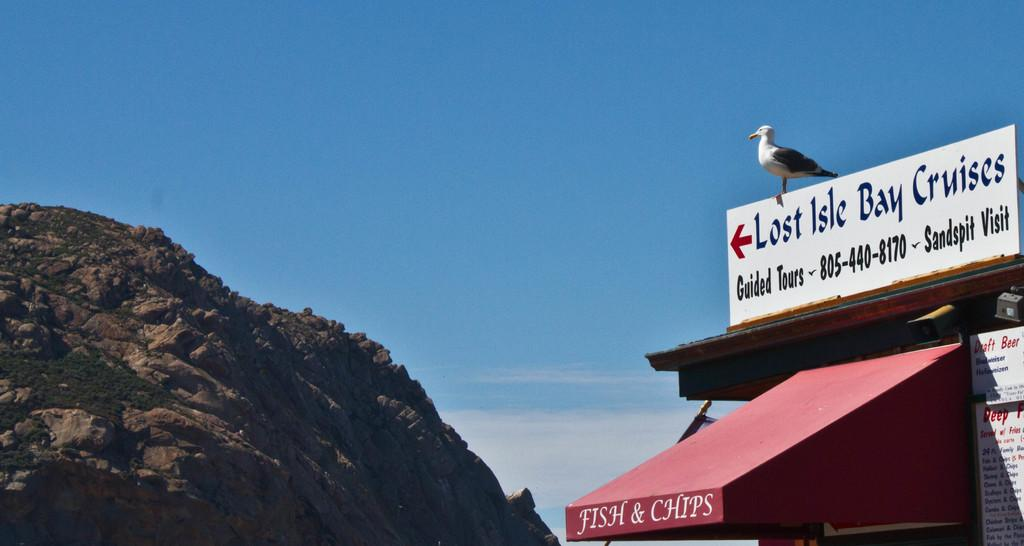<image>
Relay a brief, clear account of the picture shown. A seagull sits on a sign that show Lost Isle Bay Cruises is to the left. 